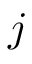<formula> <loc_0><loc_0><loc_500><loc_500>j</formula> 